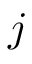<formula> <loc_0><loc_0><loc_500><loc_500>j</formula> 